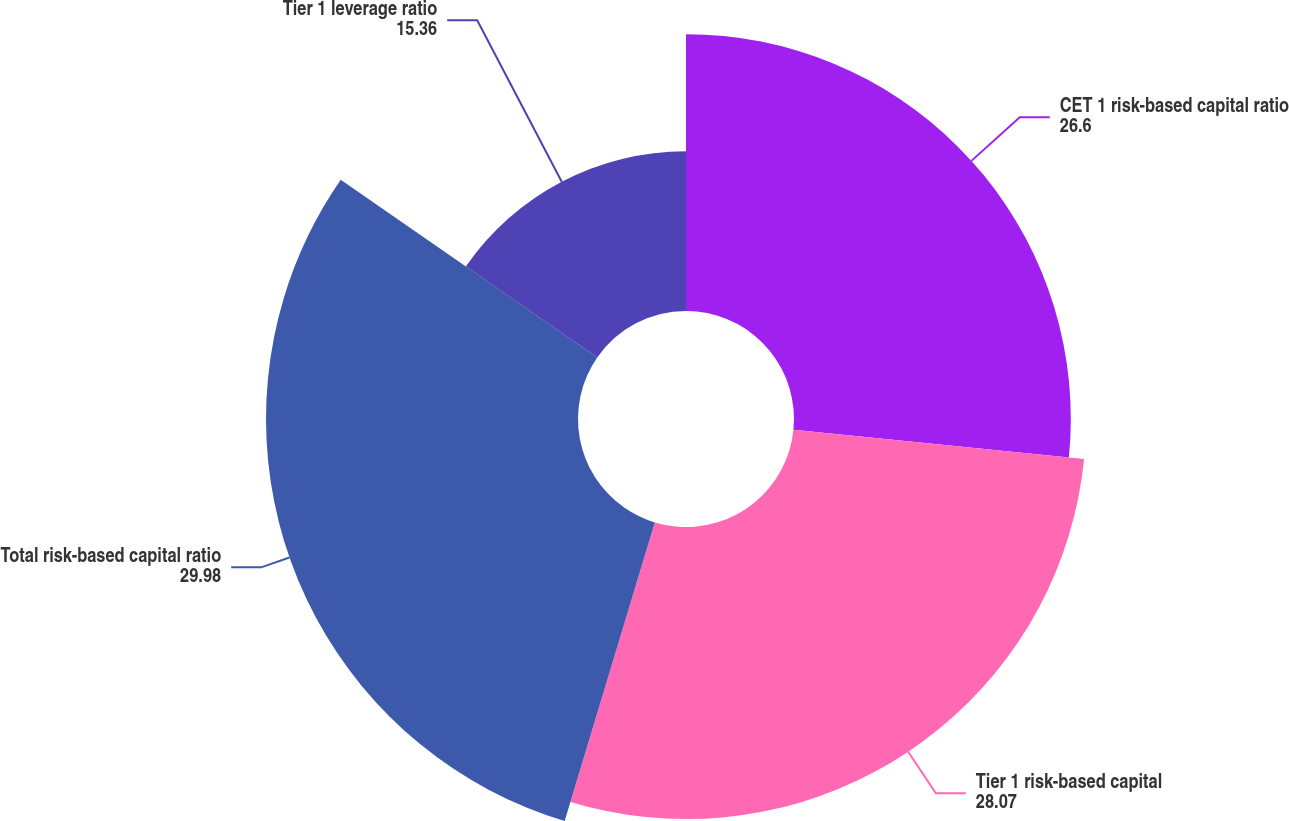Convert chart. <chart><loc_0><loc_0><loc_500><loc_500><pie_chart><fcel>CET 1 risk-based capital ratio<fcel>Tier 1 risk-based capital<fcel>Total risk-based capital ratio<fcel>Tier 1 leverage ratio<nl><fcel>26.6%<fcel>28.07%<fcel>29.98%<fcel>15.36%<nl></chart> 